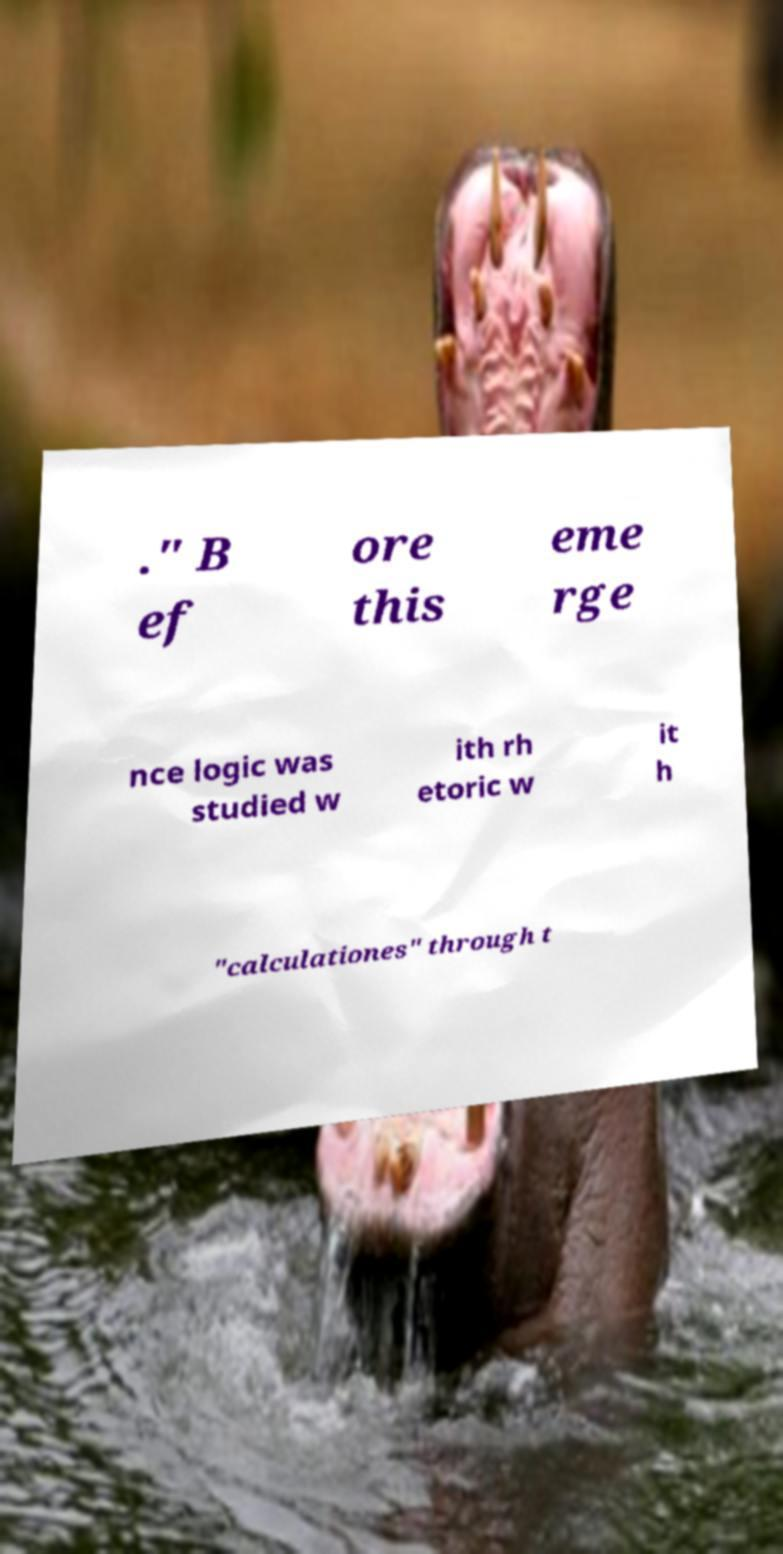I need the written content from this picture converted into text. Can you do that? ." B ef ore this eme rge nce logic was studied w ith rh etoric w it h "calculationes" through t 